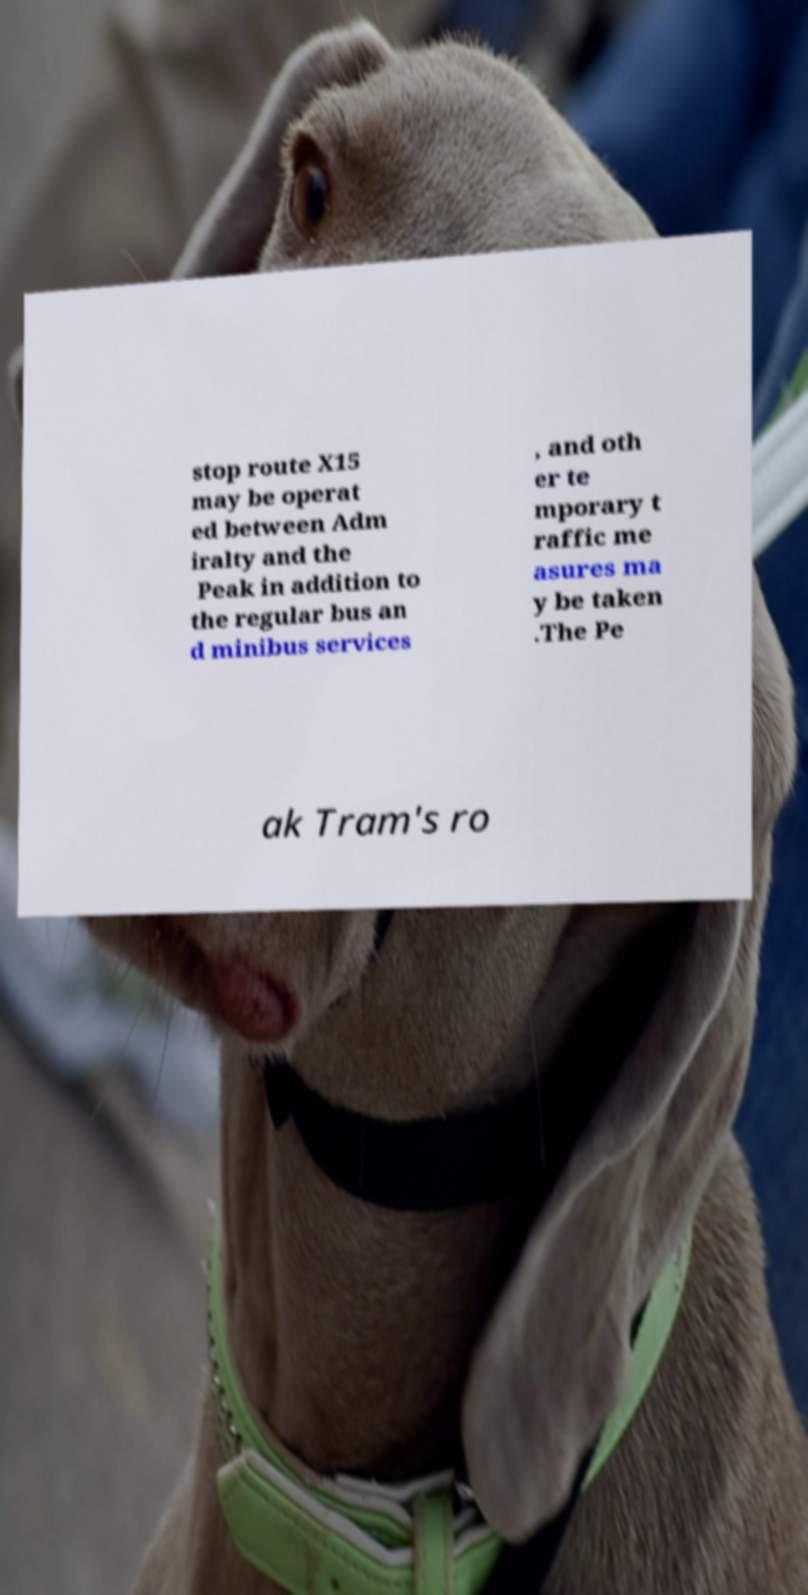For documentation purposes, I need the text within this image transcribed. Could you provide that? stop route X15 may be operat ed between Adm iralty and the Peak in addition to the regular bus an d minibus services , and oth er te mporary t raffic me asures ma y be taken .The Pe ak Tram's ro 